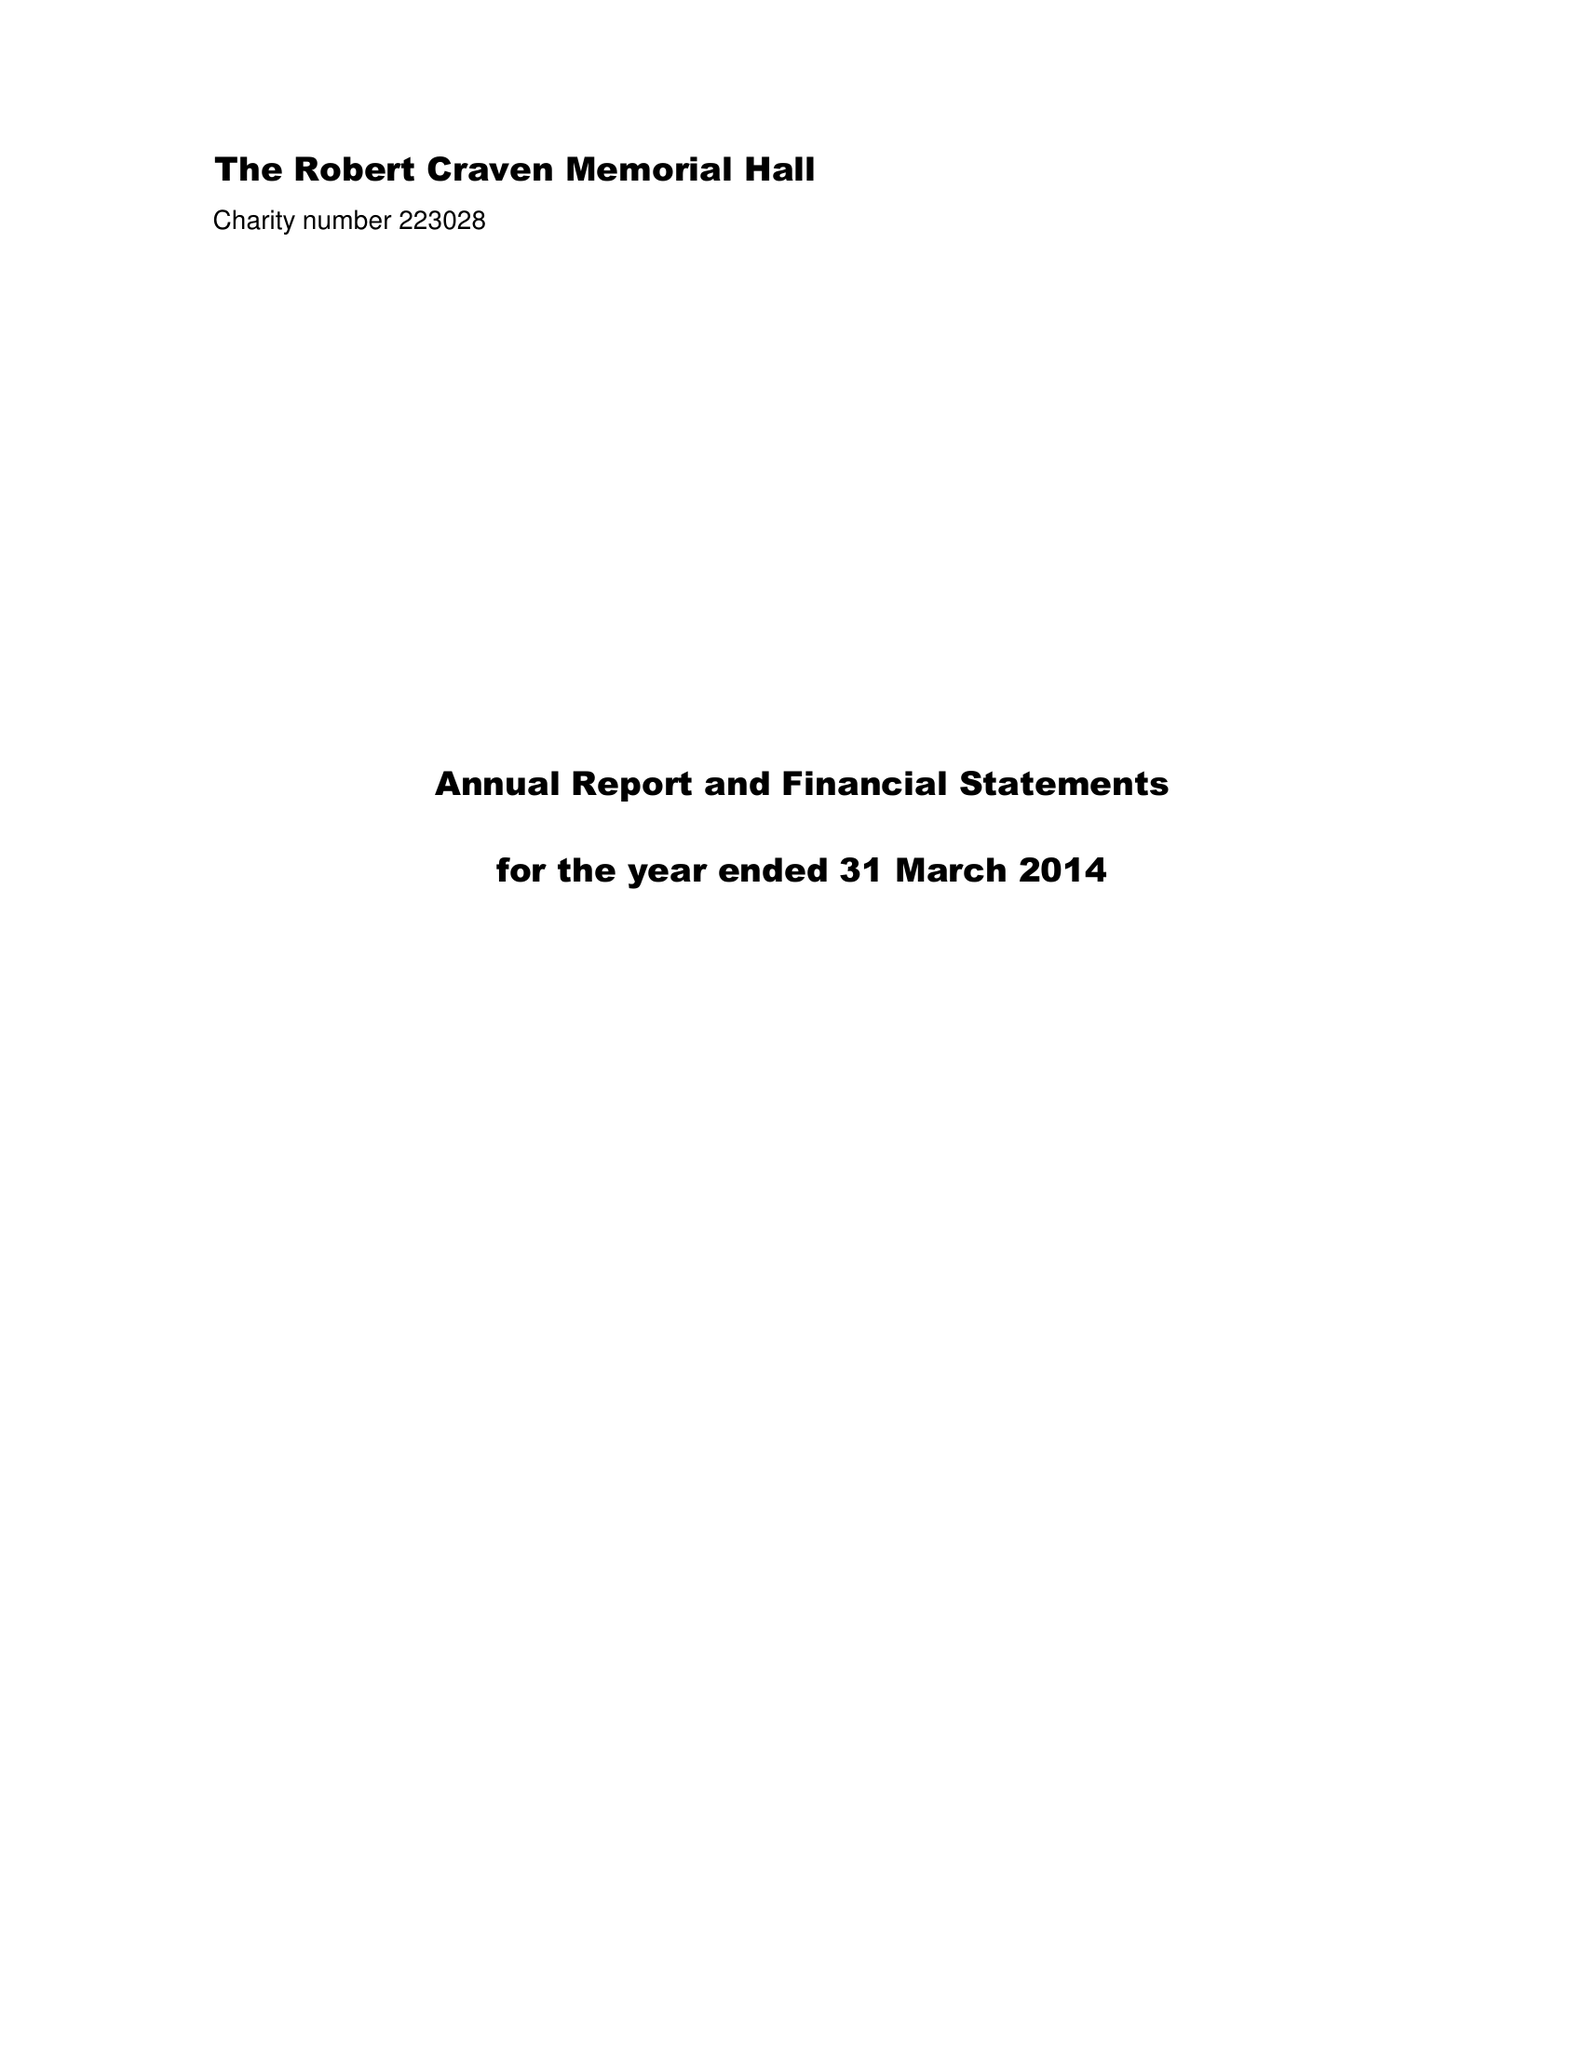What is the value for the charity_number?
Answer the question using a single word or phrase. 223028 